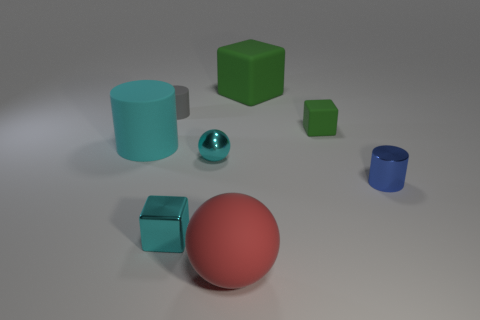Are there any gray objects that have the same size as the blue cylinder?
Provide a succinct answer. Yes. There is a thing that is behind the gray cylinder; what material is it?
Provide a succinct answer. Rubber. There is a tiny block that is made of the same material as the big red thing; what color is it?
Your answer should be very brief. Green. What number of rubber things are small cyan blocks or green blocks?
Provide a short and direct response. 2. The blue thing that is the same size as the gray rubber cylinder is what shape?
Provide a short and direct response. Cylinder. How many objects are either green matte things that are in front of the gray rubber object or things behind the cyan cylinder?
Offer a terse response. 3. There is a blue object that is the same size as the gray matte object; what is its material?
Provide a short and direct response. Metal. How many other objects are the same material as the large cyan cylinder?
Your response must be concise. 4. Are there the same number of small matte blocks behind the tiny green object and metallic things that are in front of the red object?
Provide a short and direct response. Yes. How many green things are either spheres or large matte objects?
Keep it short and to the point. 1. 